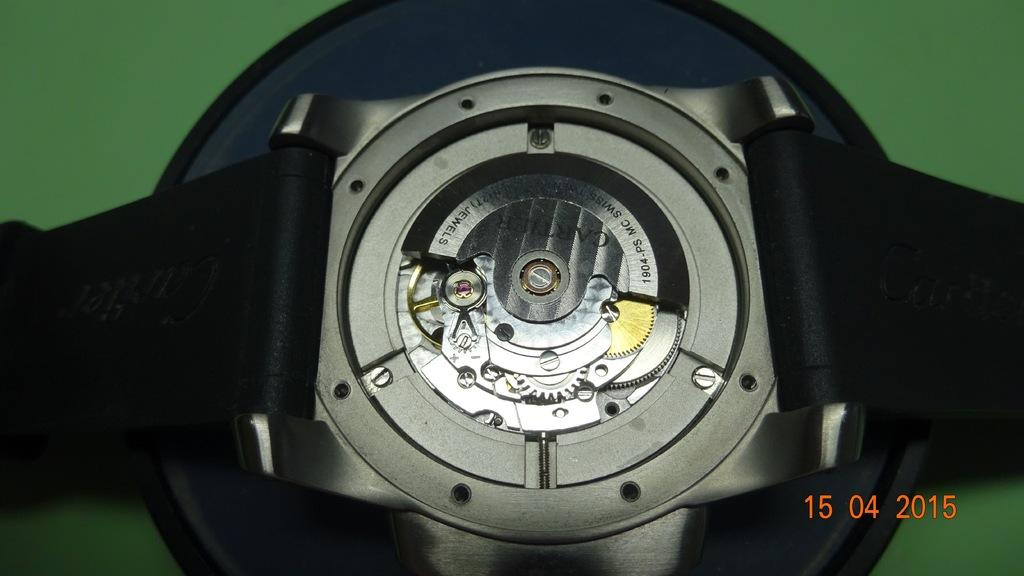<image>
Offer a succinct explanation of the picture presented. Back of a watch which has the word JEWELS on it. 